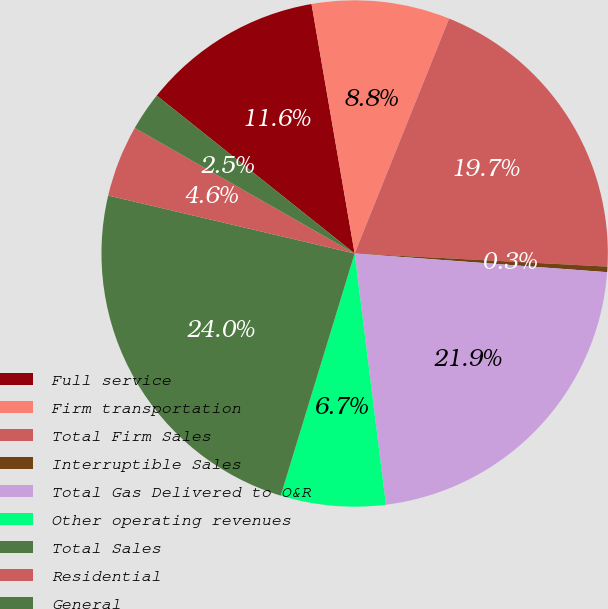Convert chart to OTSL. <chart><loc_0><loc_0><loc_500><loc_500><pie_chart><fcel>Full service<fcel>Firm transportation<fcel>Total Firm Sales<fcel>Interruptible Sales<fcel>Total Gas Delivered to O&R<fcel>Other operating revenues<fcel>Total Sales<fcel>Residential<fcel>General<nl><fcel>11.56%<fcel>8.81%<fcel>19.74%<fcel>0.35%<fcel>21.85%<fcel>6.69%<fcel>23.96%<fcel>4.58%<fcel>2.46%<nl></chart> 